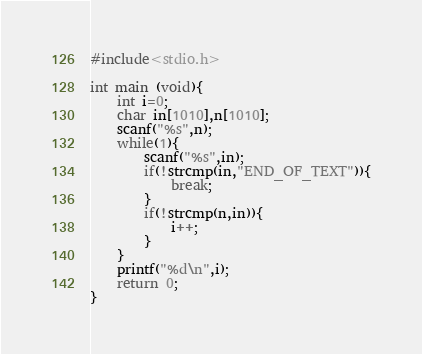<code> <loc_0><loc_0><loc_500><loc_500><_C_>#include<stdio.h>

int main (void){
	int i=0;
	char in[1010],n[1010];
	scanf("%s",n);
	while(1){
		scanf("%s",in);
		if(!strcmp(in,"END_OF_TEXT")){
			break;
		}
		if(!strcmp(n,in)){
			i++;
		}
	}
	printf("%d\n",i);
	return 0;
}</code> 